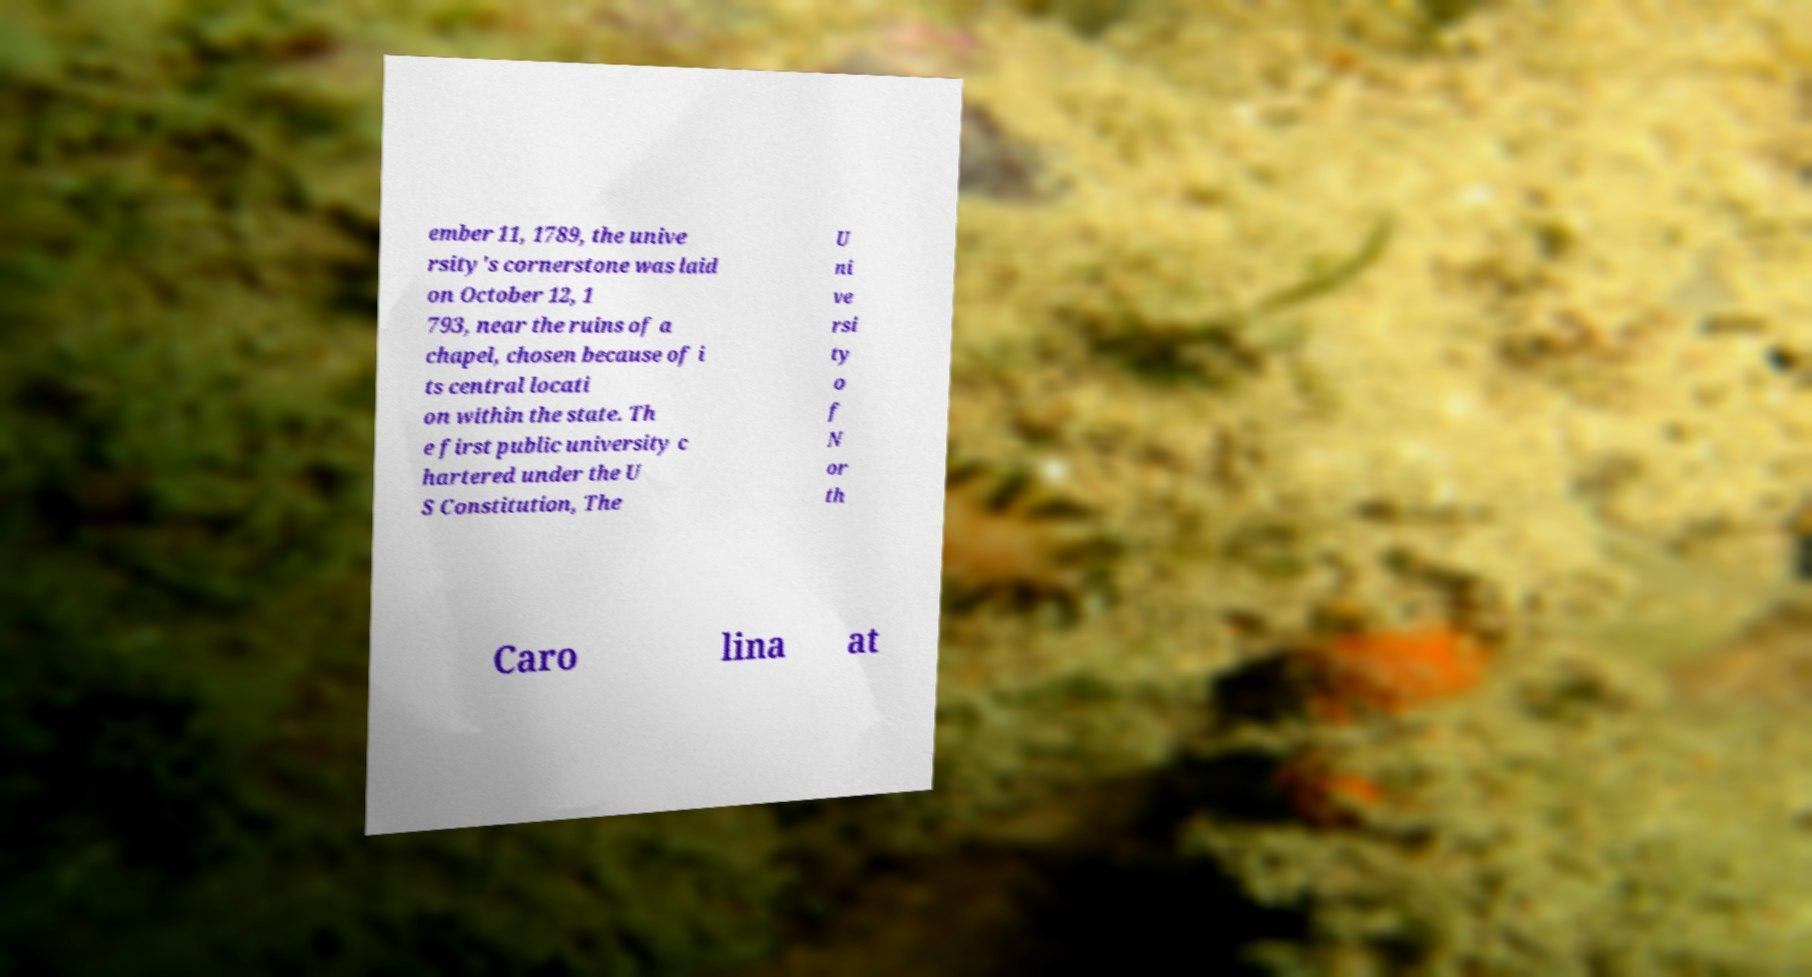I need the written content from this picture converted into text. Can you do that? ember 11, 1789, the unive rsity's cornerstone was laid on October 12, 1 793, near the ruins of a chapel, chosen because of i ts central locati on within the state. Th e first public university c hartered under the U S Constitution, The U ni ve rsi ty o f N or th Caro lina at 